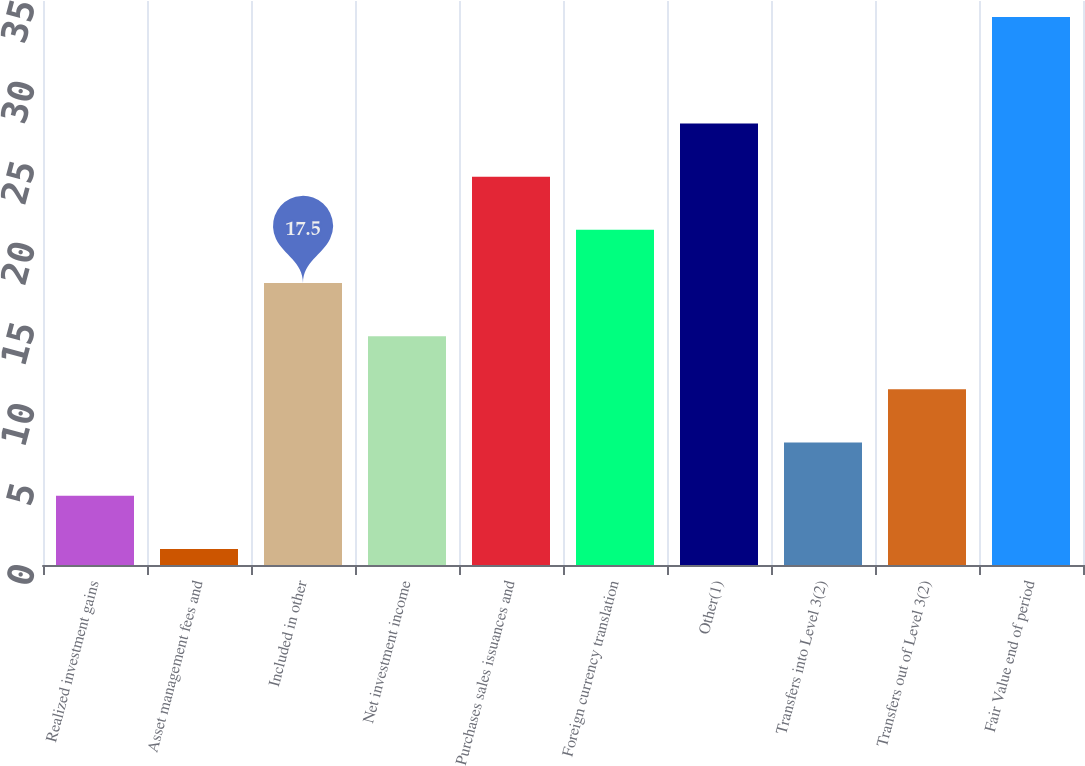Convert chart to OTSL. <chart><loc_0><loc_0><loc_500><loc_500><bar_chart><fcel>Realized investment gains<fcel>Asset management fees and<fcel>Included in other<fcel>Net investment income<fcel>Purchases sales issuances and<fcel>Foreign currency translation<fcel>Other(1)<fcel>Transfers into Level 3(2)<fcel>Transfers out of Level 3(2)<fcel>Fair Value end of period<nl><fcel>4.3<fcel>1<fcel>17.5<fcel>14.2<fcel>24.1<fcel>20.8<fcel>27.4<fcel>7.6<fcel>10.9<fcel>34<nl></chart> 